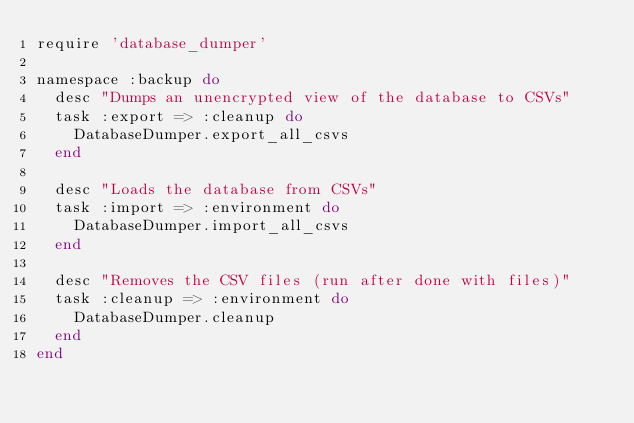<code> <loc_0><loc_0><loc_500><loc_500><_Ruby_>require 'database_dumper'

namespace :backup do
  desc "Dumps an unencrypted view of the database to CSVs"
  task :export => :cleanup do
    DatabaseDumper.export_all_csvs
  end

  desc "Loads the database from CSVs"
  task :import => :environment do
    DatabaseDumper.import_all_csvs
  end

  desc "Removes the CSV files (run after done with files)"
  task :cleanup => :environment do
    DatabaseDumper.cleanup
  end
end
</code> 